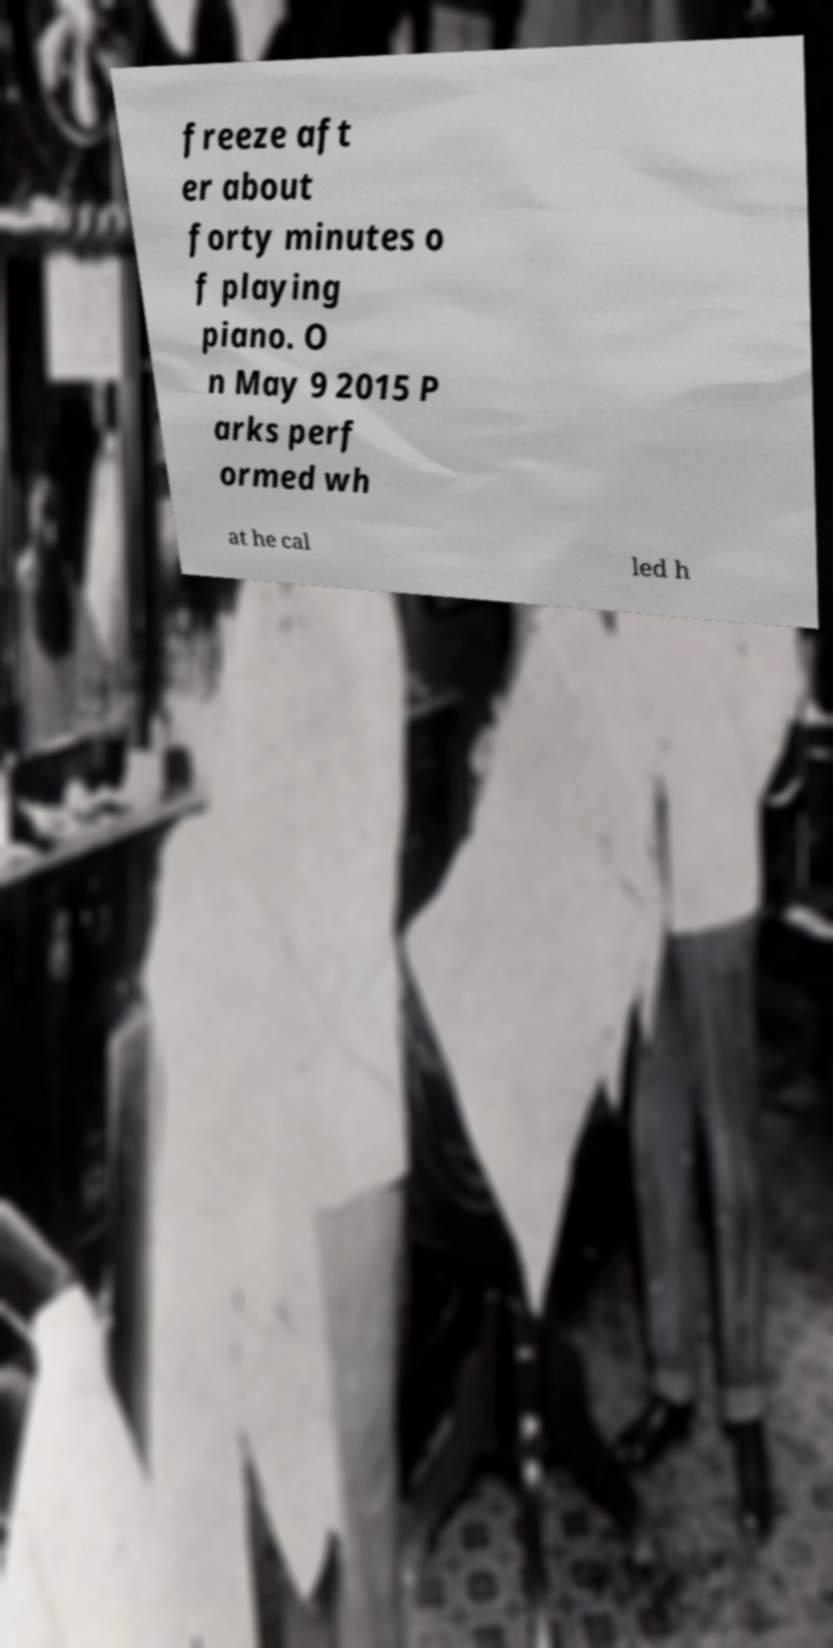Can you read and provide the text displayed in the image?This photo seems to have some interesting text. Can you extract and type it out for me? freeze aft er about forty minutes o f playing piano. O n May 9 2015 P arks perf ormed wh at he cal led h 